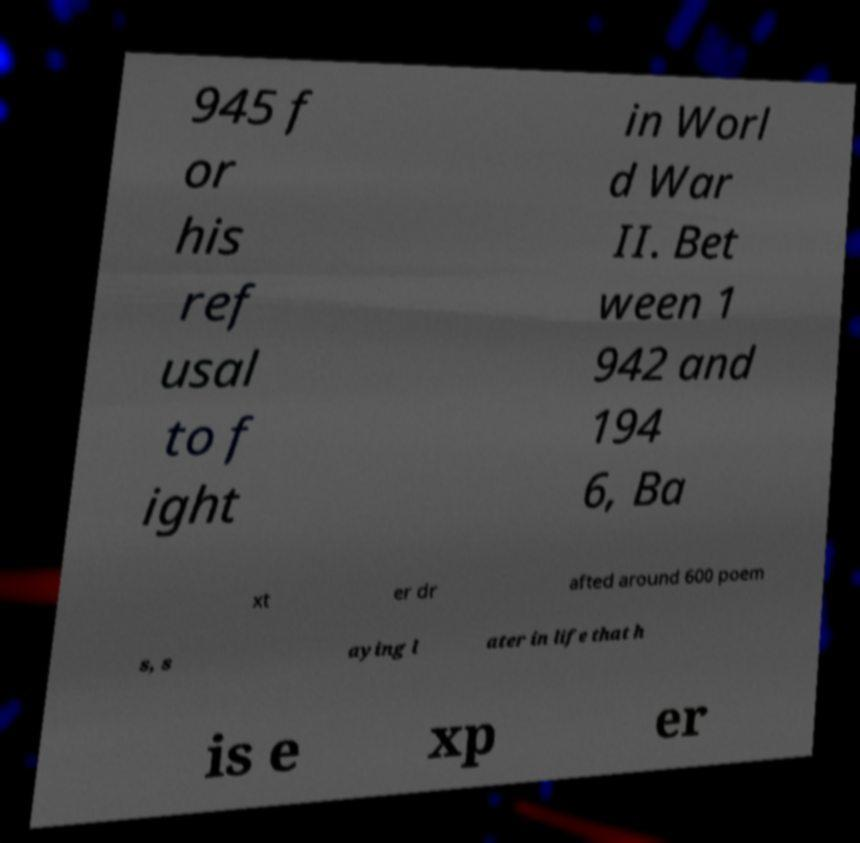Can you accurately transcribe the text from the provided image for me? 945 f or his ref usal to f ight in Worl d War II. Bet ween 1 942 and 194 6, Ba xt er dr afted around 600 poem s, s aying l ater in life that h is e xp er 